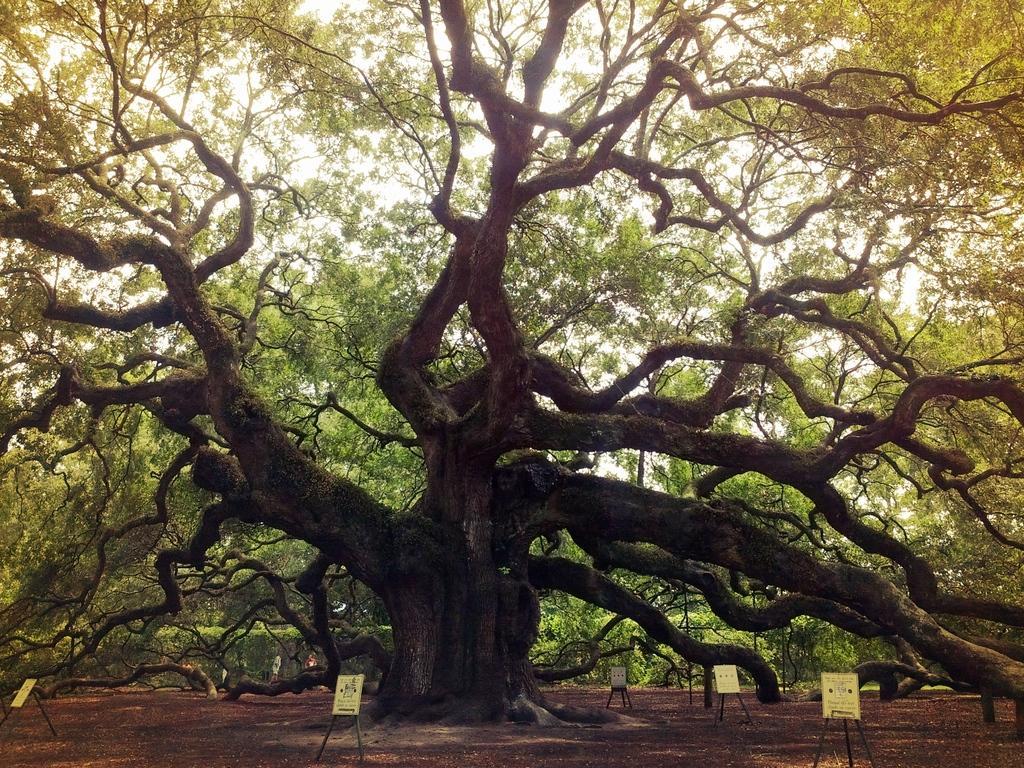Describe this image in one or two sentences. In this picture I can see a tree. I can see a few wooden stand boards. 